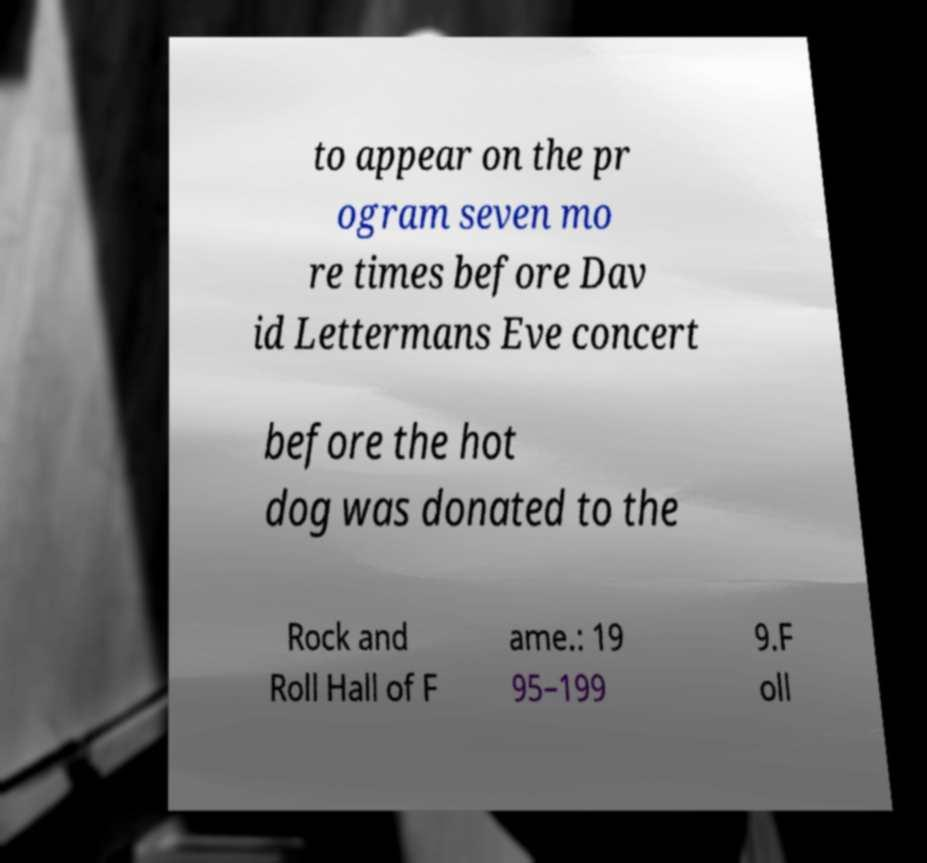Please read and relay the text visible in this image. What does it say? to appear on the pr ogram seven mo re times before Dav id Lettermans Eve concert before the hot dog was donated to the Rock and Roll Hall of F ame.: 19 95–199 9.F oll 